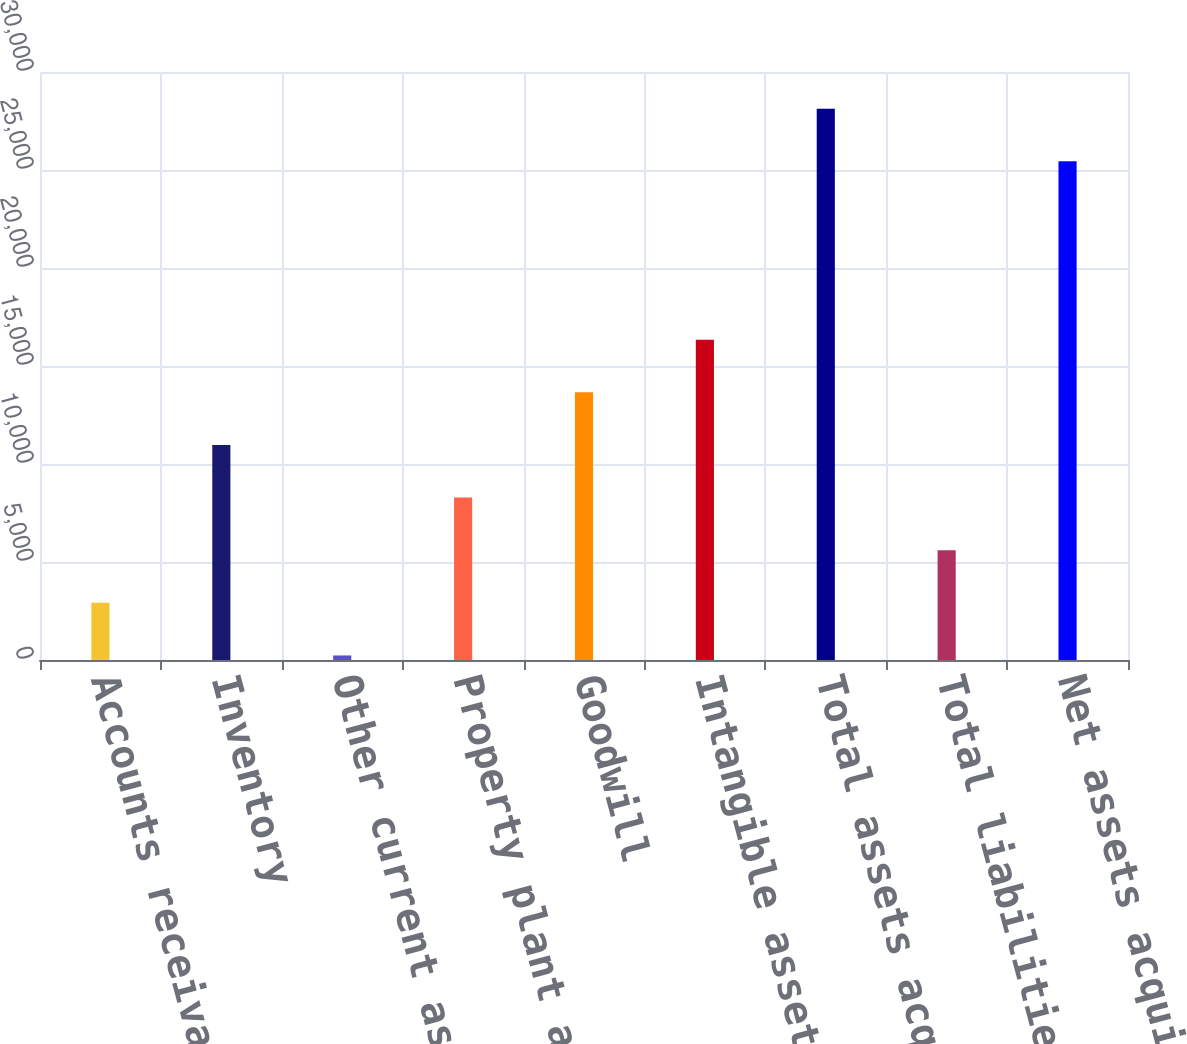<chart> <loc_0><loc_0><loc_500><loc_500><bar_chart><fcel>Accounts receivable<fcel>Inventory<fcel>Other current assets net of<fcel>Property plant and equipment<fcel>Goodwill<fcel>Intangible assets<fcel>Total assets acquired<fcel>Total liabilities assumed<fcel>Net assets acquired<nl><fcel>2916.6<fcel>10970.4<fcel>232<fcel>8285.8<fcel>13655<fcel>16339.6<fcel>28129.6<fcel>5601.2<fcel>25445<nl></chart> 